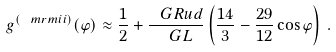Convert formula to latex. <formula><loc_0><loc_0><loc_500><loc_500>g ^ { ( \ m r m { i i } ) } ( \varphi ) \approx \frac { 1 } { 2 } + \frac { \ G R u d } { \ G L } \left ( \frac { 1 4 } { 3 } - \frac { 2 9 } { 1 2 } \cos \varphi \right ) \, .</formula> 